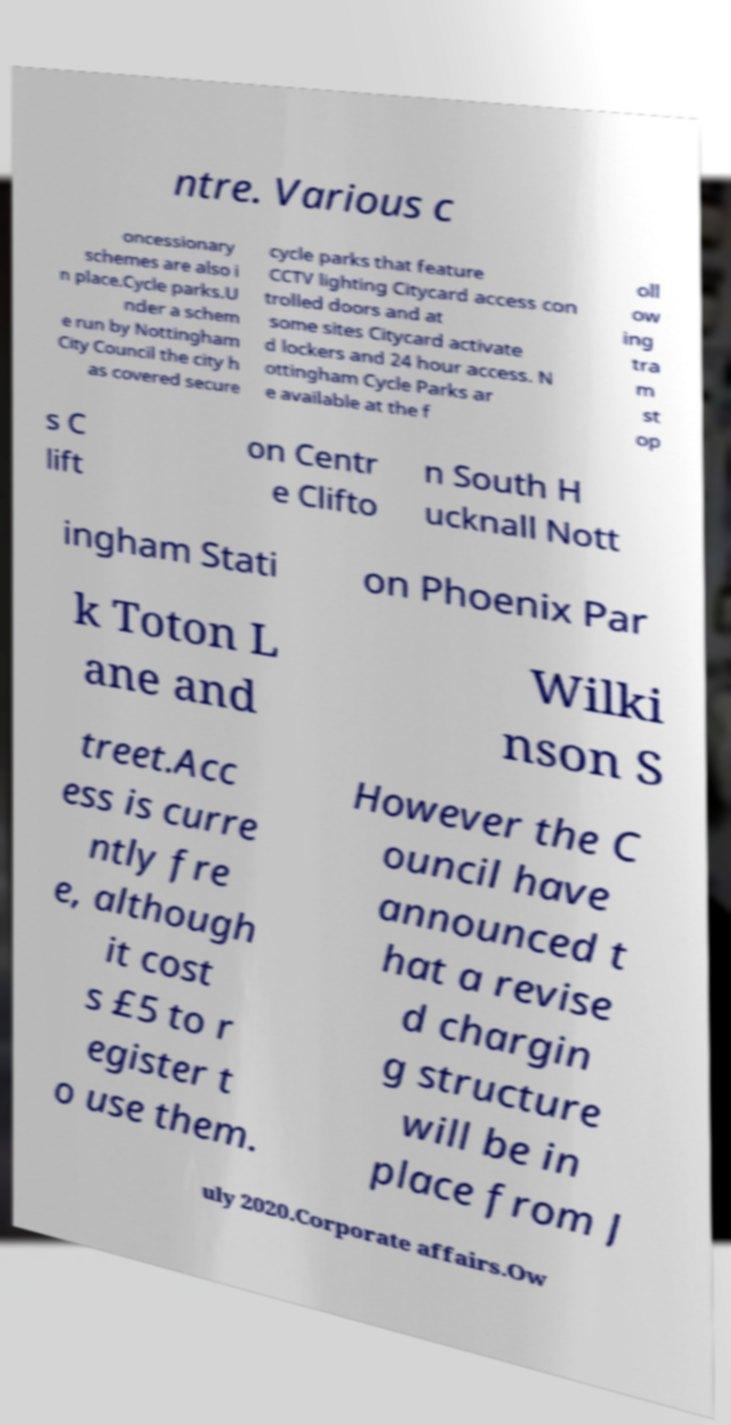What messages or text are displayed in this image? I need them in a readable, typed format. ntre. Various c oncessionary schemes are also i n place.Cycle parks.U nder a schem e run by Nottingham City Council the city h as covered secure cycle parks that feature CCTV lighting Citycard access con trolled doors and at some sites Citycard activate d lockers and 24 hour access. N ottingham Cycle Parks ar e available at the f oll ow ing tra m st op s C lift on Centr e Clifto n South H ucknall Nott ingham Stati on Phoenix Par k Toton L ane and Wilki nson S treet.Acc ess is curre ntly fre e, although it cost s £5 to r egister t o use them. However the C ouncil have announced t hat a revise d chargin g structure will be in place from J uly 2020.Corporate affairs.Ow 